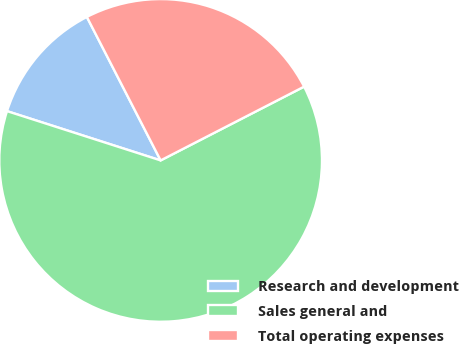Convert chart. <chart><loc_0><loc_0><loc_500><loc_500><pie_chart><fcel>Research and development<fcel>Sales general and<fcel>Total operating expenses<nl><fcel>12.5%<fcel>62.5%<fcel>25.0%<nl></chart> 